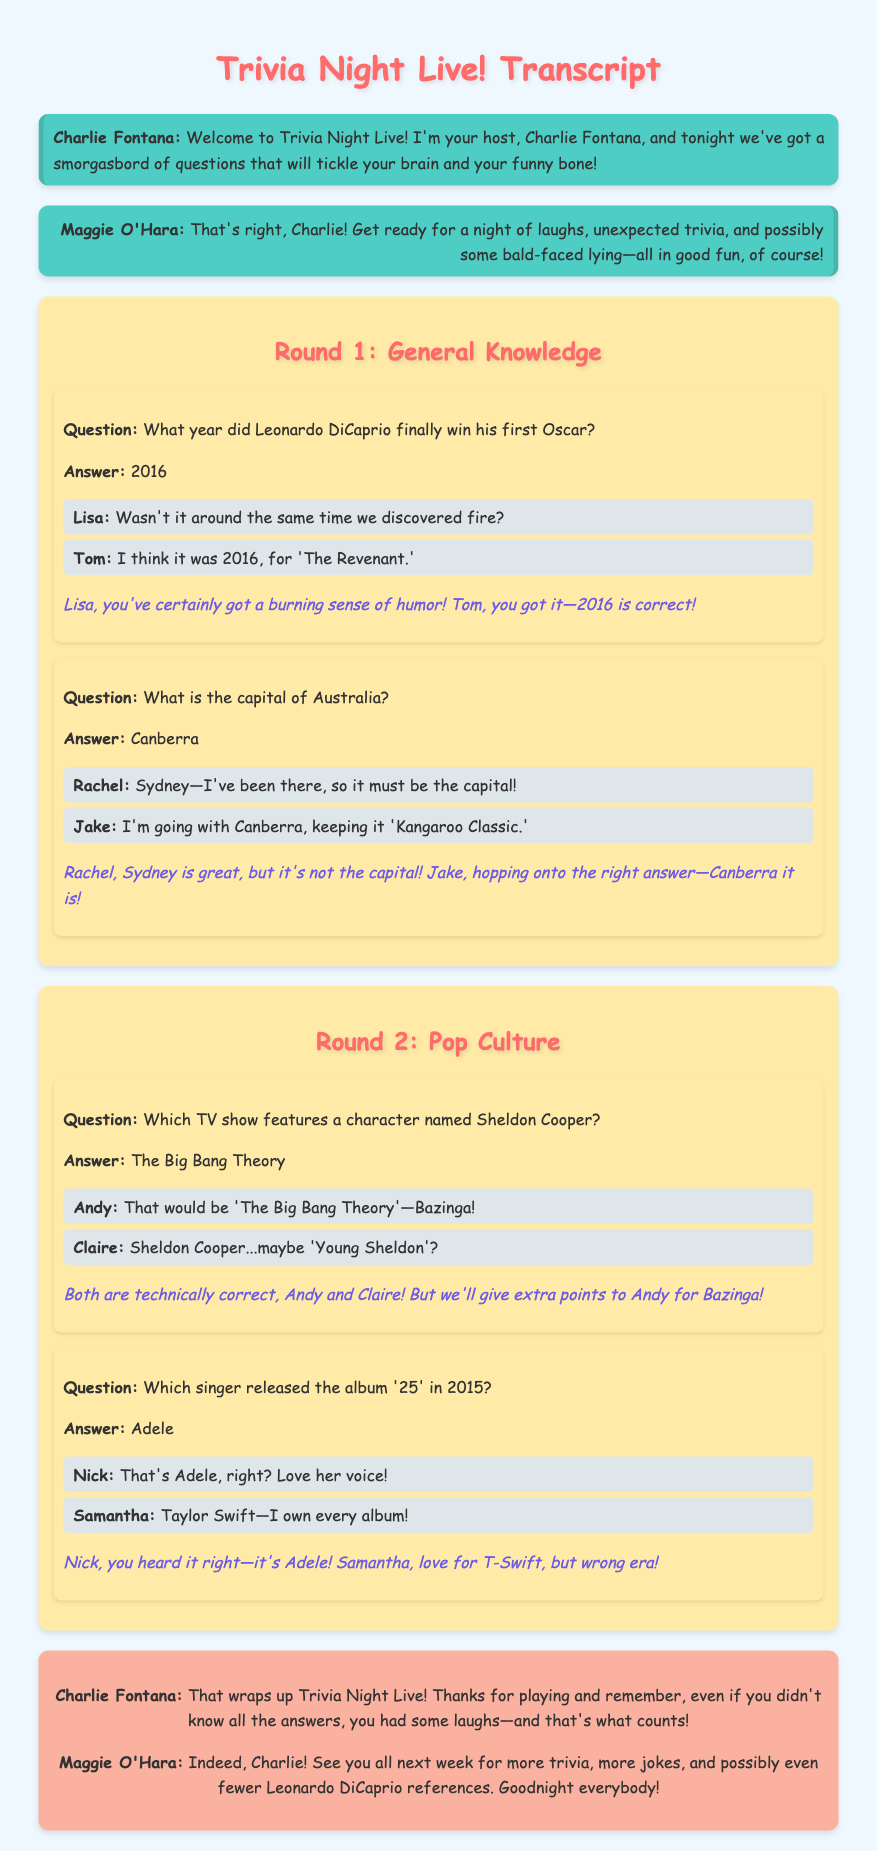What year did Leonardo DiCaprio win his first Oscar? The document states that Leonardo DiCaprio won his first Oscar in 2016.
Answer: 2016 What is the capital of Australia? The document reveals that the capital of Australia is Canberra.
Answer: Canberra Which TV show features a character named Sheldon Cooper? According to the document, the TV show featuring Sheldon Cooper is The Big Bang Theory.
Answer: The Big Bang Theory Who released the album '25' in 2015? The transcript identifies Adele as the singer who released the album '25' in 2015.
Answer: Adele What is the co-host's name? The document names the co-host as Maggie O'Hara.
Answer: Maggie O'Hara What type of humor is emphasized in the event? The document highlights that the trivia night includes witty and humorous elements.
Answer: Humorous What phrase did Andy use related to Sheldon Cooper? Andy used the phrase "Bazinga" in reference to Sheldon Cooper.
Answer: Bazinga What does Charlie Fontana thank players for at the end? Charlie Fontana thanks players for participating in the trivia night, emphasizing the fun aspect despite not knowing all answers.
Answer: Playing 